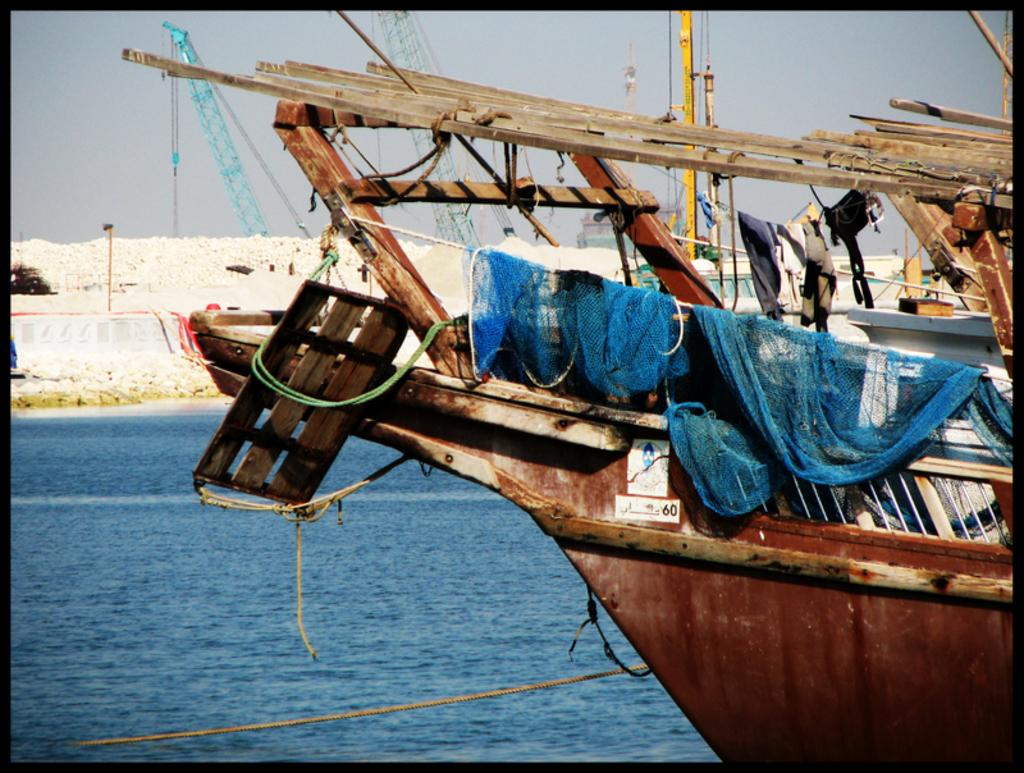What is on the water in the image? There are ships on the water in the image. What type of objects can be seen near the water? There are stones visible in the image. What structures are present in the image? There are cranes in the image. What can be seen in the background of the image? The sky is visible in the background of the image. Where are the pizzas being prepared in the image? There are no pizzas or pizza-making facilities present in the image. What type of wax is being used to coat the stones in the image? There is no wax or wax-related activity in the image; the stones are simply visible. 